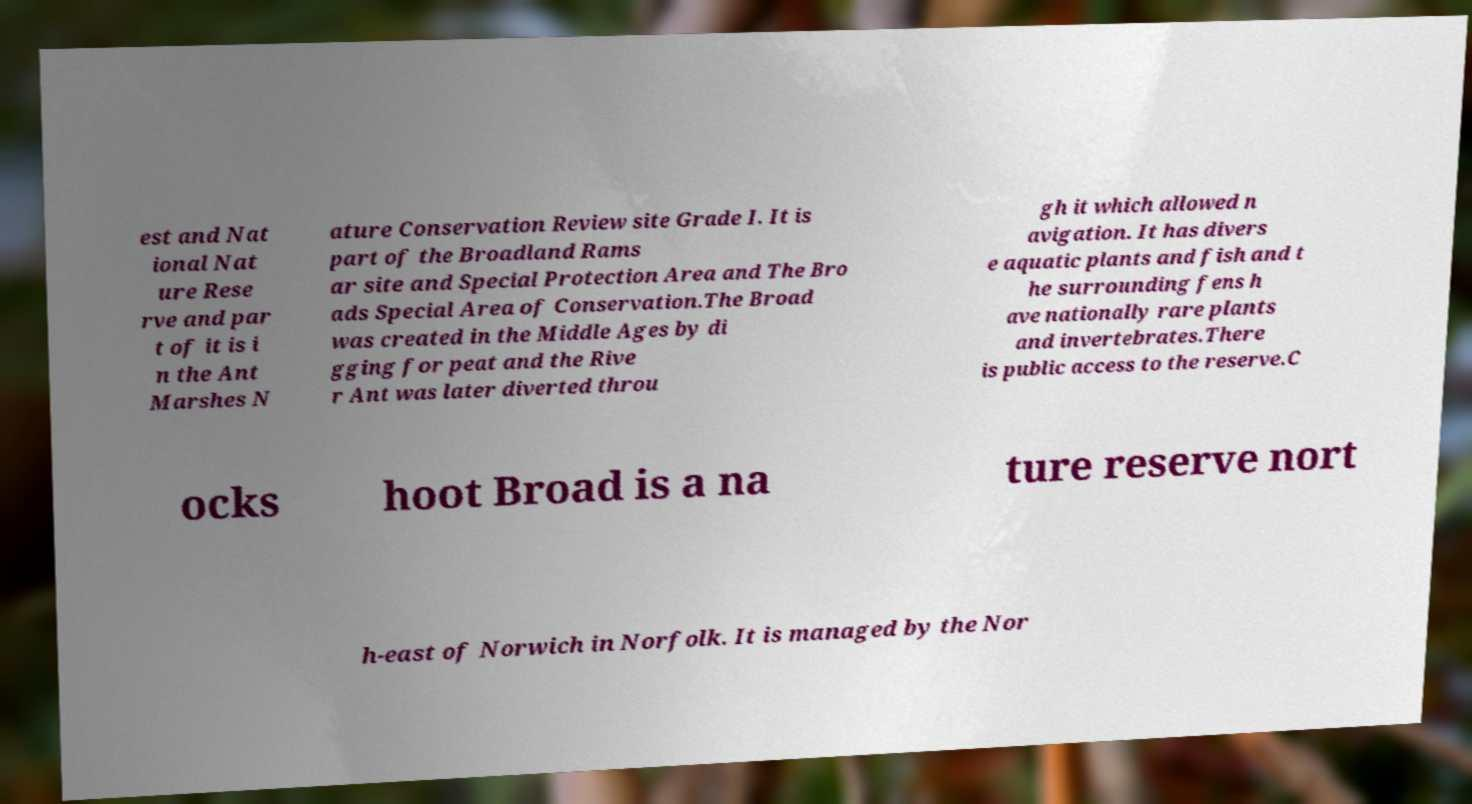Can you accurately transcribe the text from the provided image for me? est and Nat ional Nat ure Rese rve and par t of it is i n the Ant Marshes N ature Conservation Review site Grade I. It is part of the Broadland Rams ar site and Special Protection Area and The Bro ads Special Area of Conservation.The Broad was created in the Middle Ages by di gging for peat and the Rive r Ant was later diverted throu gh it which allowed n avigation. It has divers e aquatic plants and fish and t he surrounding fens h ave nationally rare plants and invertebrates.There is public access to the reserve.C ocks hoot Broad is a na ture reserve nort h-east of Norwich in Norfolk. It is managed by the Nor 